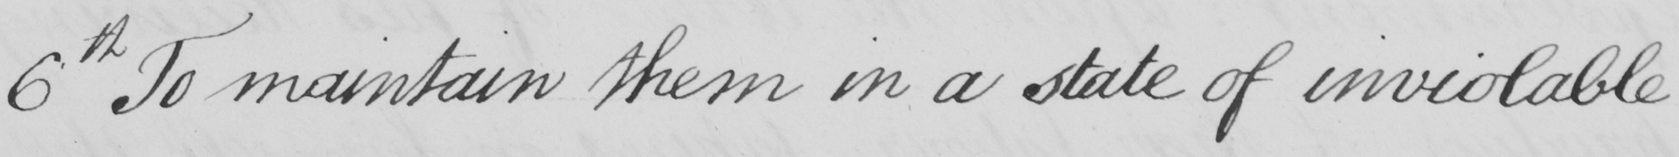Can you read and transcribe this handwriting? 6th To maintain them in a state of inviolable 